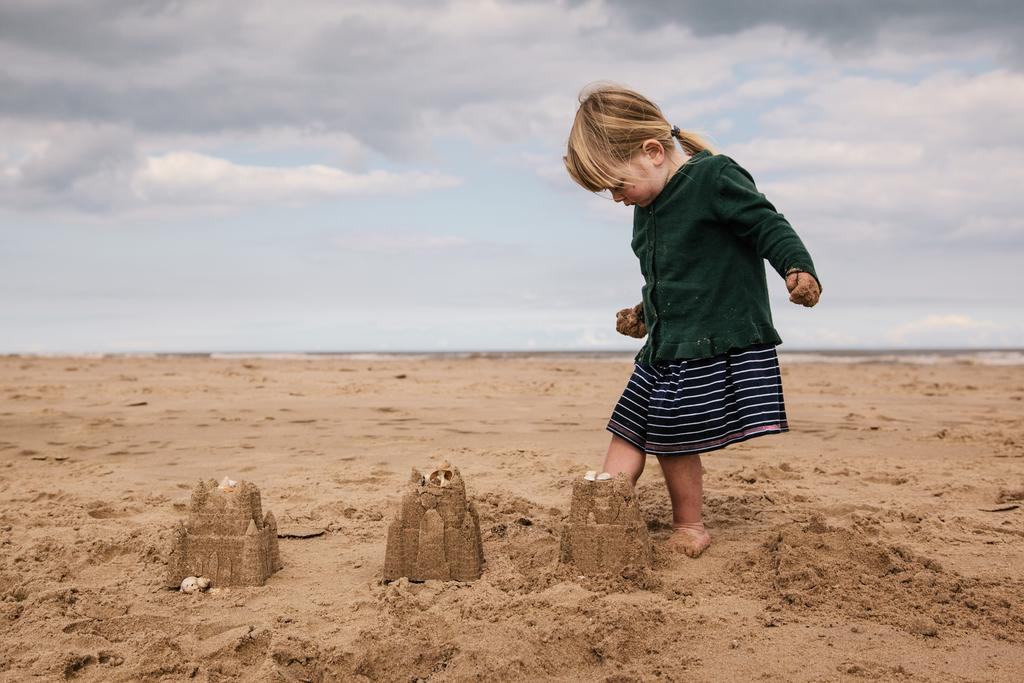What is the girl standing on in the image? The girl is standing on the sand in the image. What can be seen built on the sand in the image? There are sand houses in the image. What is visible in the background of the image? Sky is visible in the background of the image. What can be observed in the sky in the image? Clouds are present in the sky. What type of silver is being used to build the sand houses in the image? There is no silver present in the image; the sand houses are made entirely of sand. 